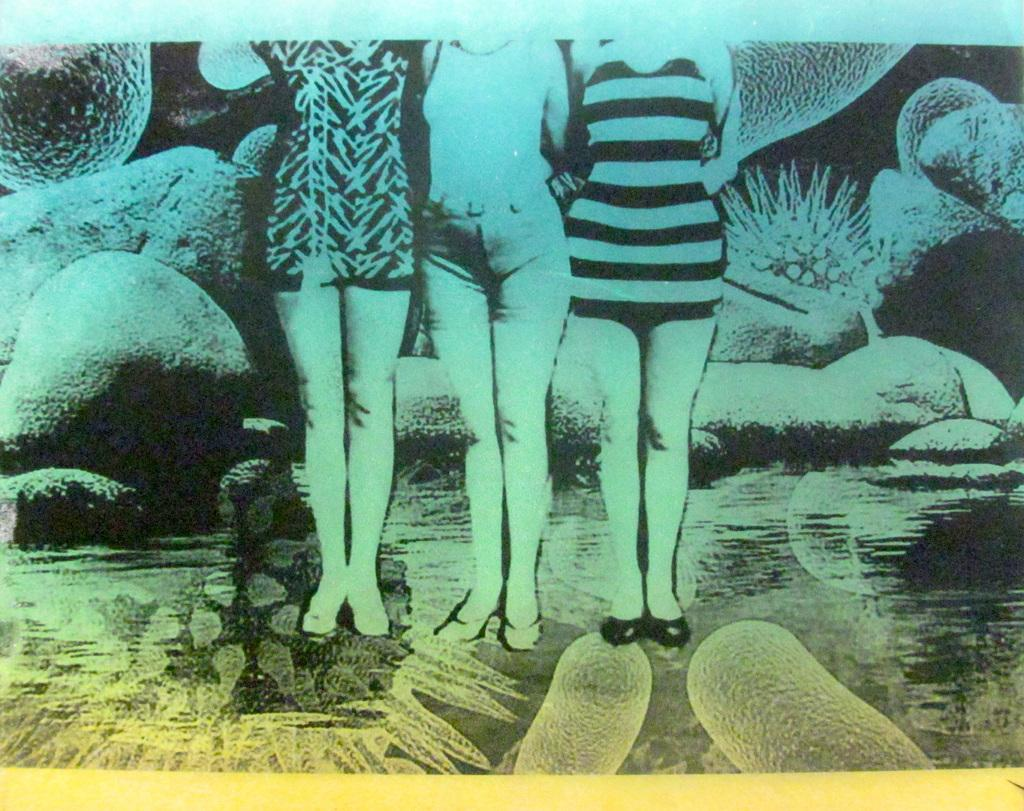How many people are present in the image? There are three persons standing in the image. Can you describe the background of the image? There are rocks visible in the background of the image. What type of sheet is covering the rocks in the image? There is no sheet present in the image; the rocks are visible without any covering. 